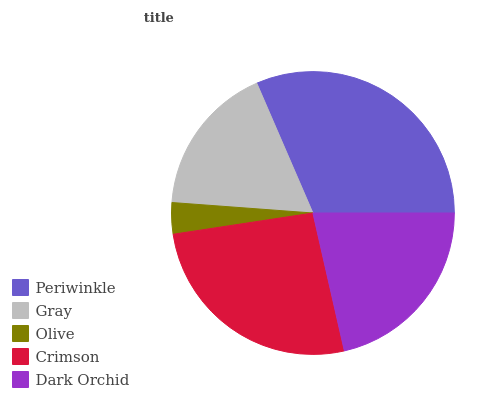Is Olive the minimum?
Answer yes or no. Yes. Is Periwinkle the maximum?
Answer yes or no. Yes. Is Gray the minimum?
Answer yes or no. No. Is Gray the maximum?
Answer yes or no. No. Is Periwinkle greater than Gray?
Answer yes or no. Yes. Is Gray less than Periwinkle?
Answer yes or no. Yes. Is Gray greater than Periwinkle?
Answer yes or no. No. Is Periwinkle less than Gray?
Answer yes or no. No. Is Dark Orchid the high median?
Answer yes or no. Yes. Is Dark Orchid the low median?
Answer yes or no. Yes. Is Crimson the high median?
Answer yes or no. No. Is Periwinkle the low median?
Answer yes or no. No. 